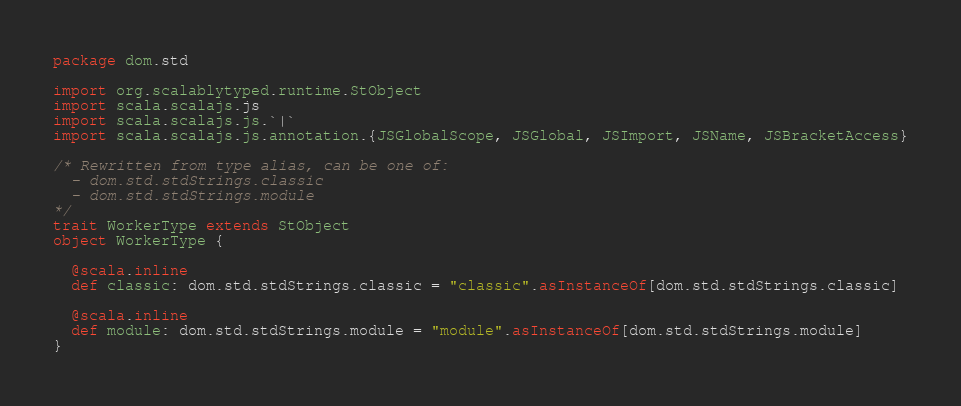<code> <loc_0><loc_0><loc_500><loc_500><_Scala_>package dom.std

import org.scalablytyped.runtime.StObject
import scala.scalajs.js
import scala.scalajs.js.`|`
import scala.scalajs.js.annotation.{JSGlobalScope, JSGlobal, JSImport, JSName, JSBracketAccess}

/* Rewritten from type alias, can be one of: 
  - dom.std.stdStrings.classic
  - dom.std.stdStrings.module
*/
trait WorkerType extends StObject
object WorkerType {
  
  @scala.inline
  def classic: dom.std.stdStrings.classic = "classic".asInstanceOf[dom.std.stdStrings.classic]
  
  @scala.inline
  def module: dom.std.stdStrings.module = "module".asInstanceOf[dom.std.stdStrings.module]
}
</code> 